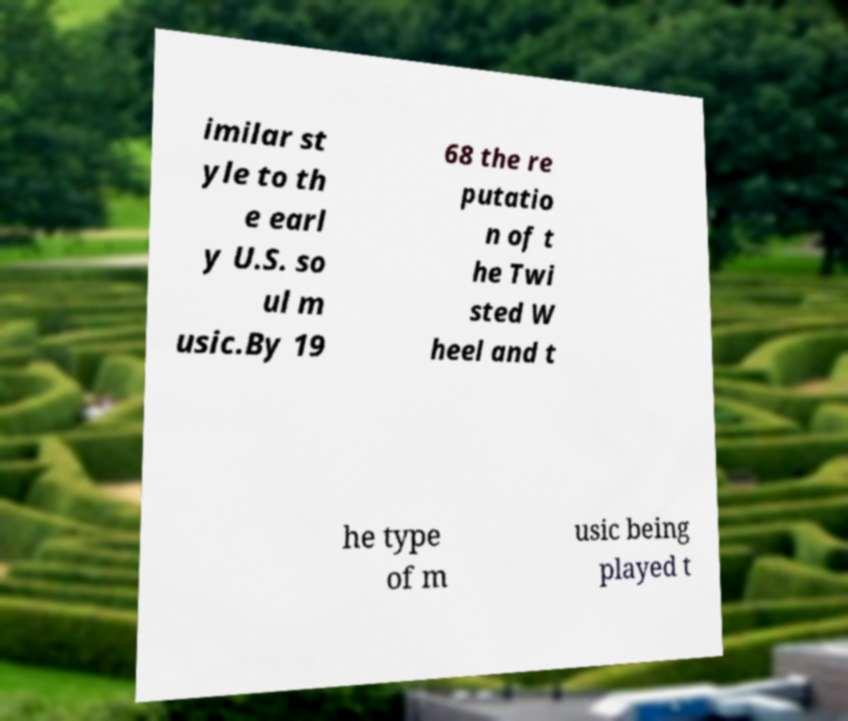Please identify and transcribe the text found in this image. imilar st yle to th e earl y U.S. so ul m usic.By 19 68 the re putatio n of t he Twi sted W heel and t he type of m usic being played t 